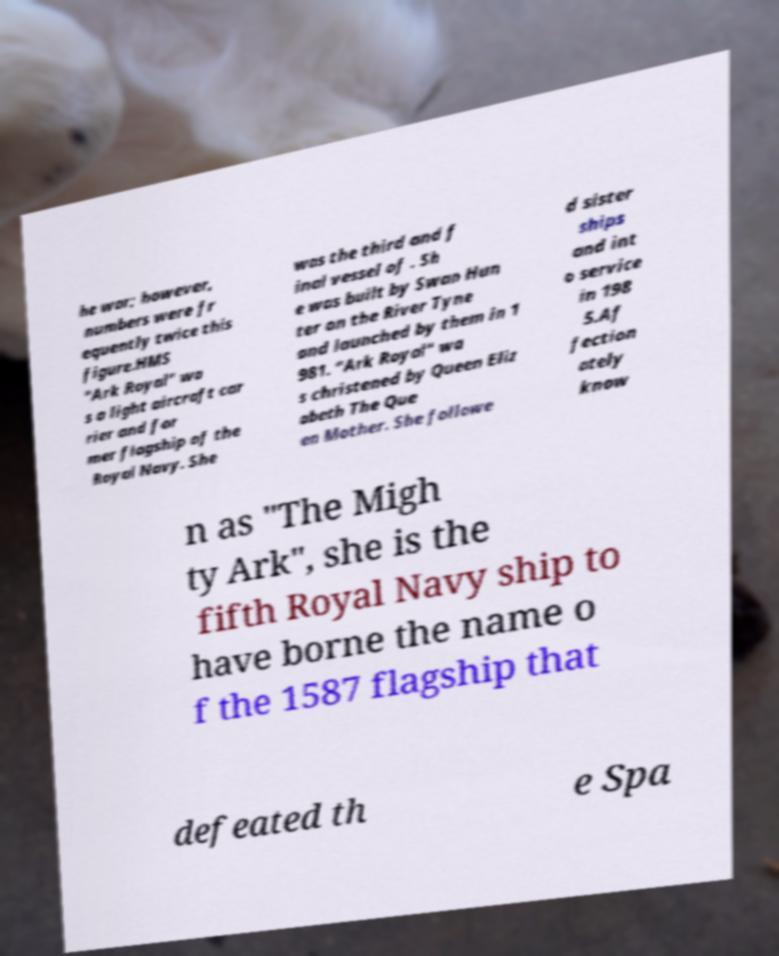Please read and relay the text visible in this image. What does it say? he war; however, numbers were fr equently twice this figure.HMS "Ark Royal" wa s a light aircraft car rier and for mer flagship of the Royal Navy. She was the third and f inal vessel of . Sh e was built by Swan Hun ter on the River Tyne and launched by them in 1 981. "Ark Royal" wa s christened by Queen Eliz abeth The Que en Mother. She followe d sister ships and int o service in 198 5.Af fection ately know n as "The Migh ty Ark", she is the fifth Royal Navy ship to have borne the name o f the 1587 flagship that defeated th e Spa 